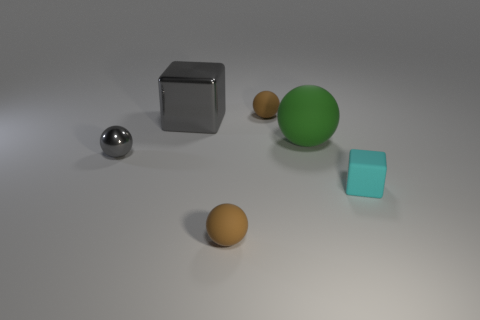Subtract 1 spheres. How many spheres are left? 3 Add 4 brown matte things. How many objects exist? 10 Subtract all spheres. How many objects are left? 2 Add 6 big gray cubes. How many big gray cubes exist? 7 Subtract 1 cyan blocks. How many objects are left? 5 Subtract all green matte spheres. Subtract all small gray balls. How many objects are left? 4 Add 2 cyan matte cubes. How many cyan matte cubes are left? 3 